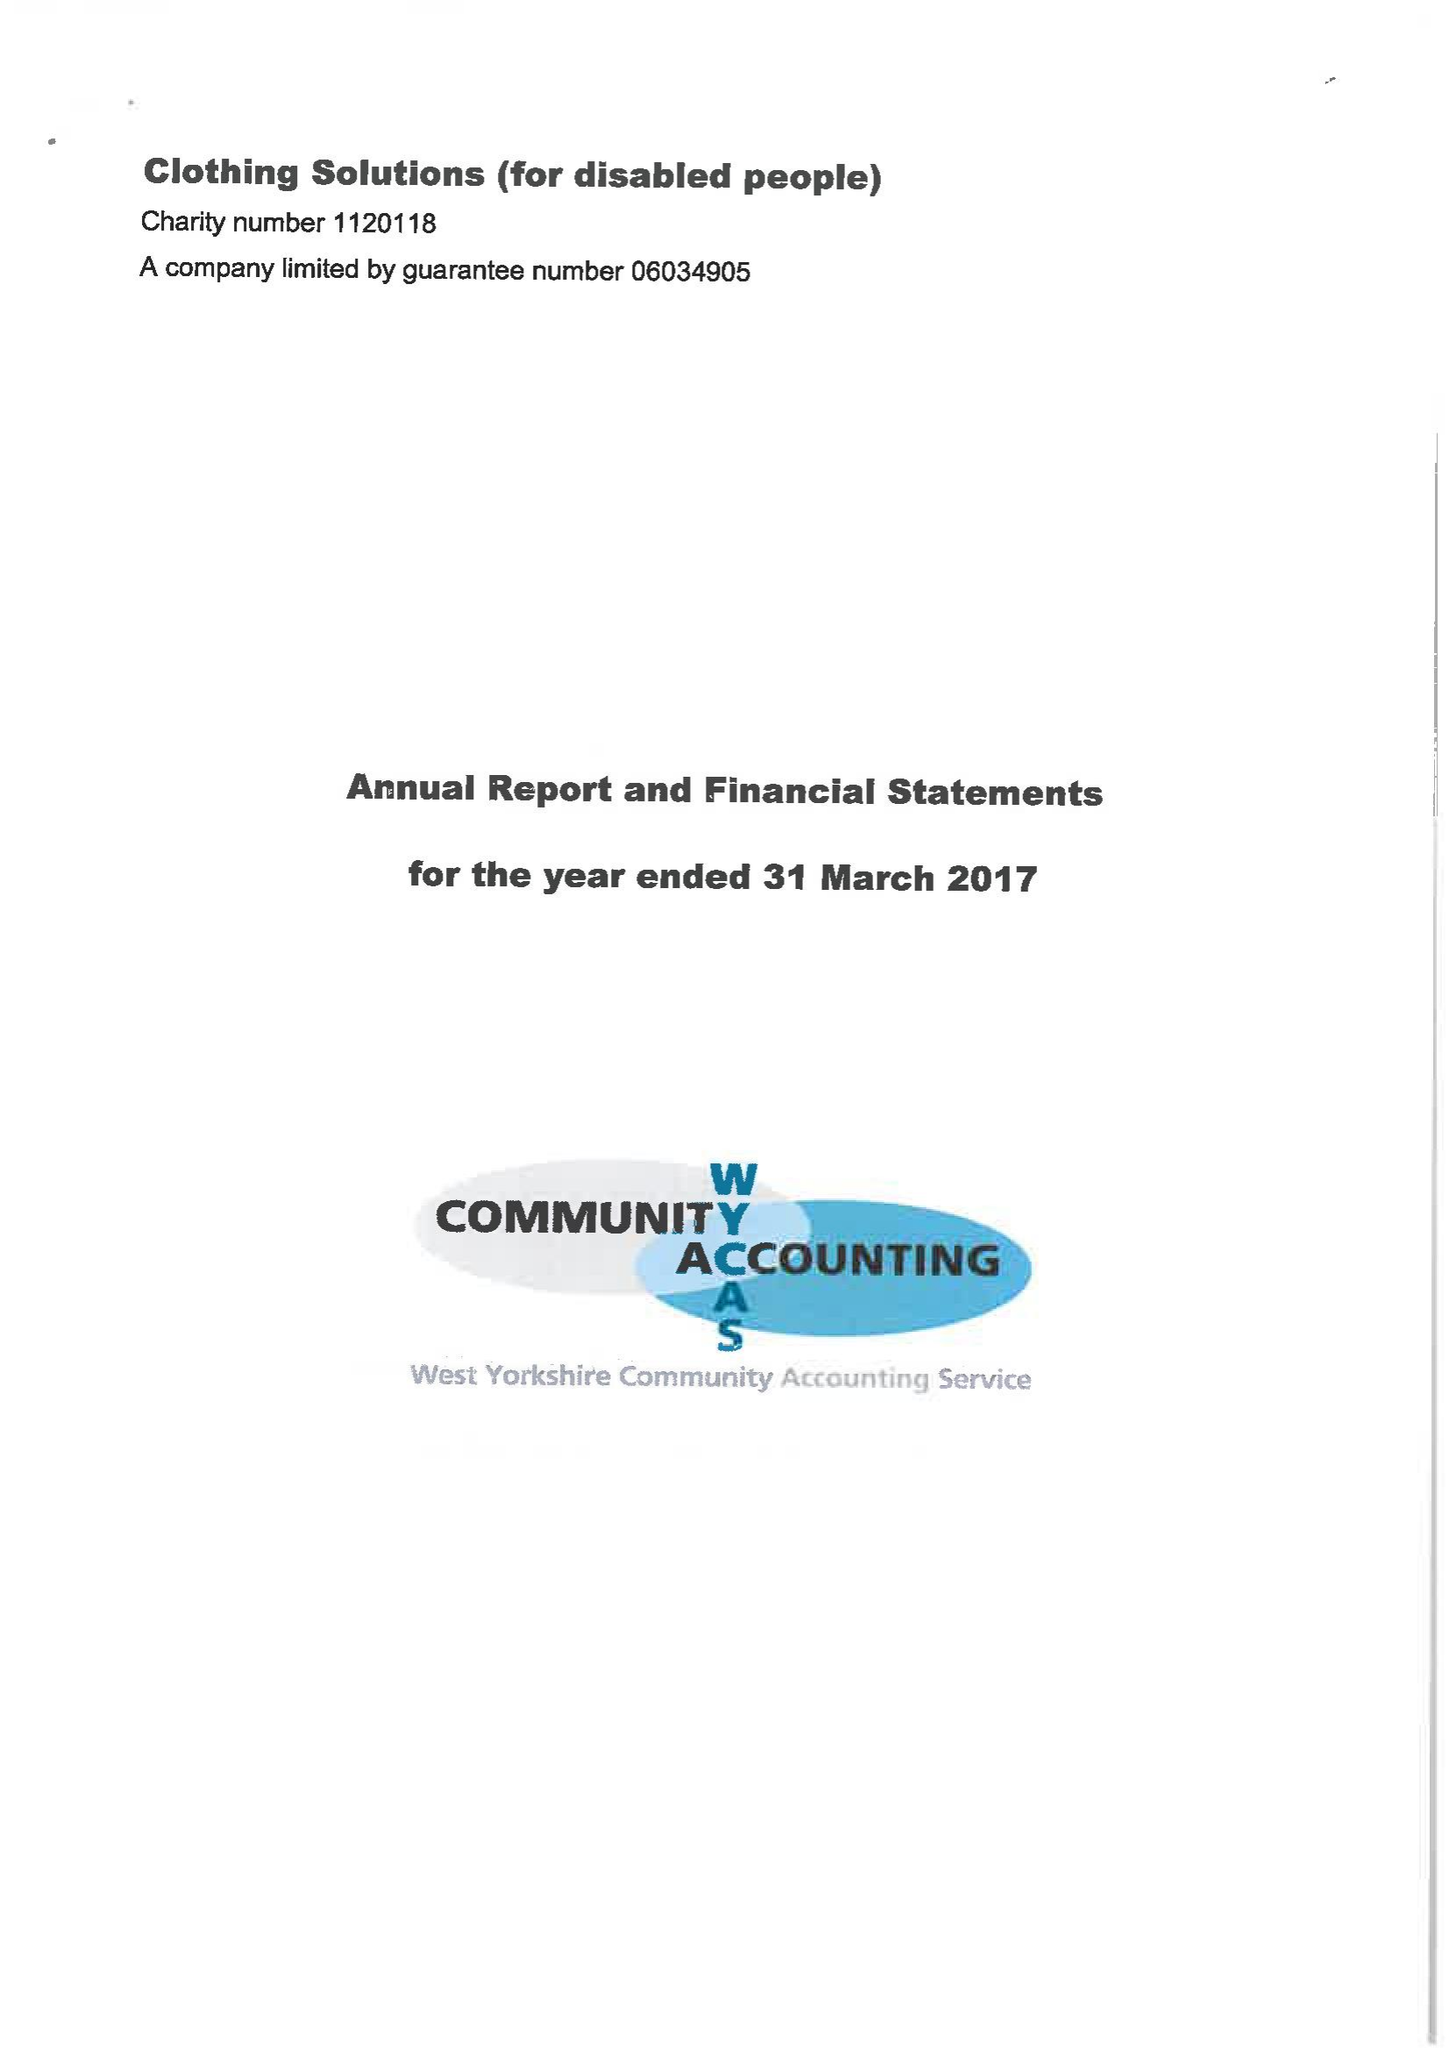What is the value for the address__street_line?
Answer the question using a single word or phrase. None 